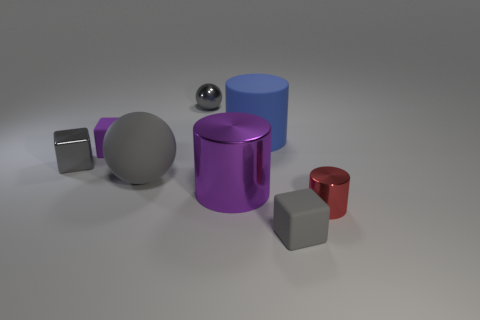Add 2 small cylinders. How many objects exist? 10 Subtract all gray blocks. How many blocks are left? 1 Subtract all cylinders. How many objects are left? 5 Subtract all green cubes. How many brown balls are left? 0 Subtract all small blue cylinders. Subtract all big gray rubber objects. How many objects are left? 7 Add 4 small cylinders. How many small cylinders are left? 5 Add 6 metal spheres. How many metal spheres exist? 7 Subtract all purple blocks. How many blocks are left? 2 Subtract 0 cyan cylinders. How many objects are left? 8 Subtract 2 spheres. How many spheres are left? 0 